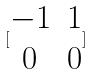<formula> <loc_0><loc_0><loc_500><loc_500>[ \begin{matrix} - 1 & 1 \\ 0 & 0 \end{matrix} ]</formula> 